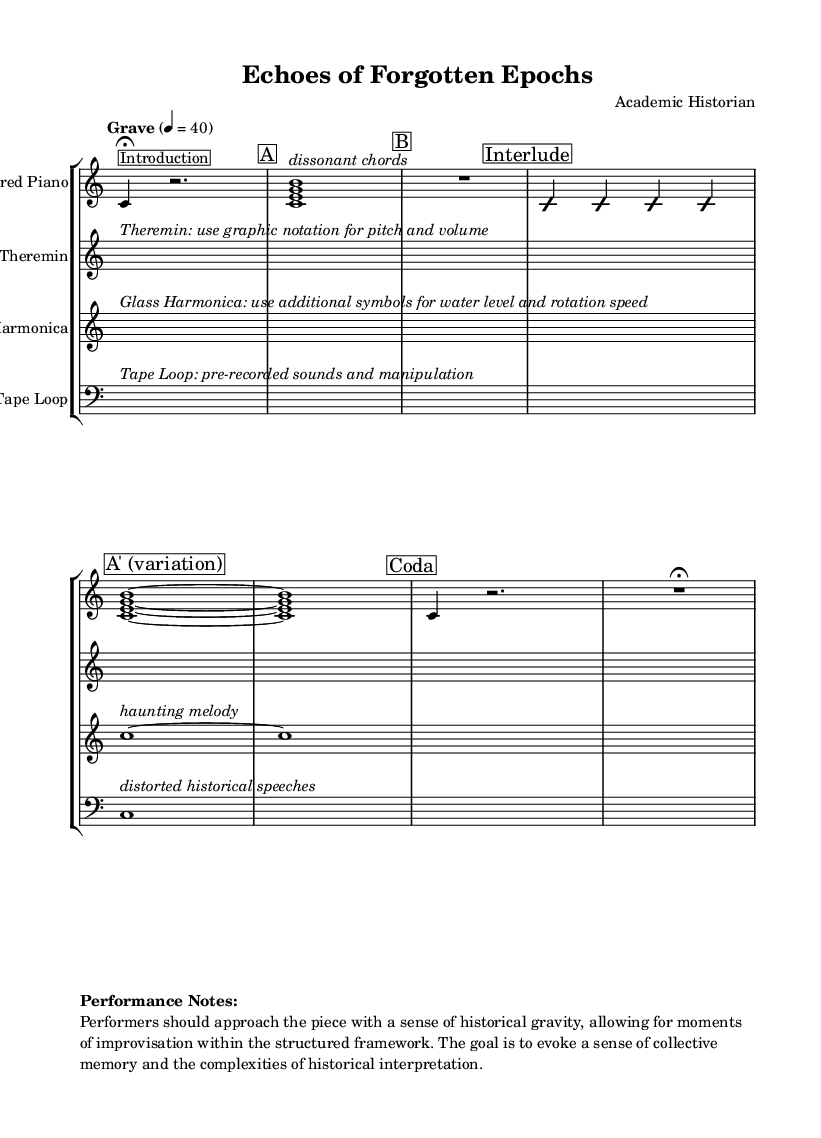What is the time signature of this music? The time signature is indicated at the beginning with a "4/4", meaning there are four beats in a measure and the quarter note gets one beat.
Answer: 4/4 What is the tempo marking for this piece? The tempo marking is given as "Grave", which indicates a slow and solemn pace, specifically around 40 beats per minute.
Answer: Grave What instrument is indicated for the first staff? The first staff is labeled as "Prepared Piano", which shows that this specific instrument is meant to perform the music written in that staff.
Answer: Prepared Piano How many measures are in Section A? Section A consists of one measure, as indicated by the single bar containing the chord notated in this section.
Answer: 1 What type of notation is used for the theremin? The notation for the theremin is described as "graphic notation", which involves non-standard symbols for pitch and volume, as indicated in the music.
Answer: Graphic notation How does the interplay between sections contribute to the historical theme? The music layout suggests an interplay of structured sections and improvisation, allowing performers to reflect on historical memory, particularly in the interlude and varying sections.
Answer: Improvisation and structure What is the purpose of the tape loop in this piece? The tape loop serves as a medium for incorporating pre-recorded sounds and manipulating them, as indicated in the instructions, contributing to the overall experimental sound.
Answer: Pre-recorded sounds and manipulation 